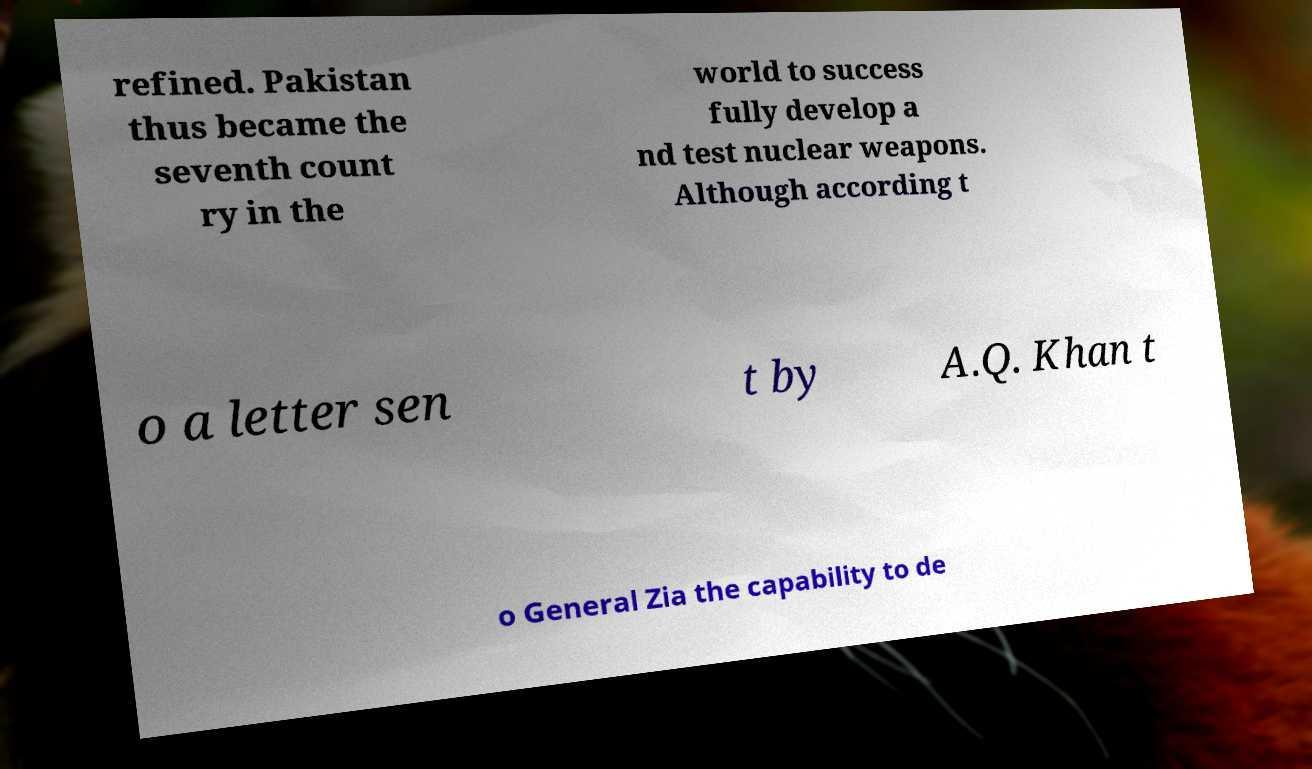Could you extract and type out the text from this image? refined. Pakistan thus became the seventh count ry in the world to success fully develop a nd test nuclear weapons. Although according t o a letter sen t by A.Q. Khan t o General Zia the capability to de 